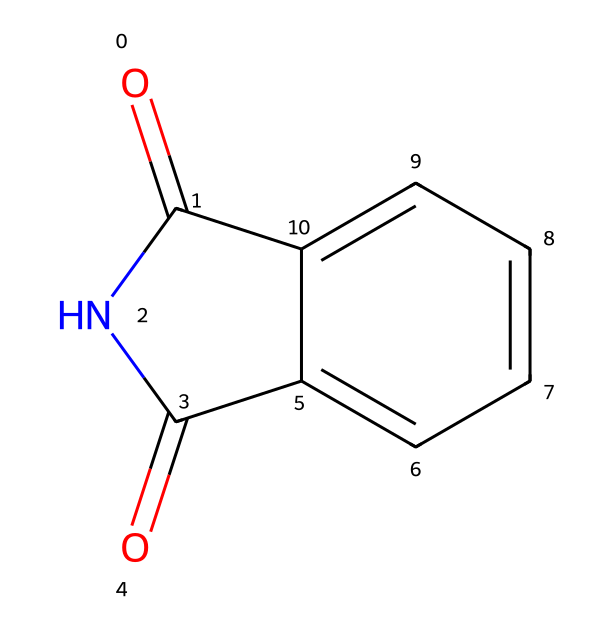What is the functional group present in phthalimide? The molecule has a carbonyl group (C=O) attached to a nitrogen, which classifies it as an imide. This can be determined by observing the structure, where the nitrogen is bonded to two carbonyls.
Answer: imide How many carbon atoms are in phthalimide? By examining the SMILES representation, we see two carbonyl carbons and five additional carbon atoms in the aromatic ring, leading to a total of seven carbon atoms.
Answer: seven What is the aromatic system present in phthalimide? The structure contains a phenyl ring (a benzene derivative), as indicated by the six carbon atoms in a cyclic arrangement with alternating double bonds. This is typical for aromatic compounds.
Answer: phenyl ring How many rings are in the molecular structure of phthalimide? The SMILES structure shows one five-membered ring (the imide ring) and one six-membered ring (the aromatic ring), totaling two rings in the molecule.
Answer: two What type of reaction commonly uses phthalimide? Phthalimide is used in the Gabriel synthesis, a method for preparing primary amines, which is indicated by its presence as an intermediate in the synthesis process.
Answer: Gabriel synthesis What is the total number of nitrogen atoms in phthalimide? Analyzing the structure, there is one nitrogen atom in the imide functional group present in phthalimide.
Answer: one 